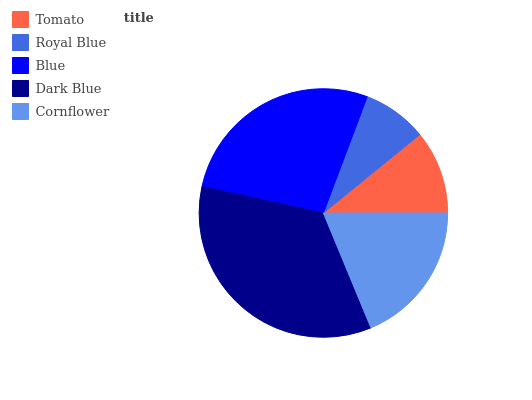Is Royal Blue the minimum?
Answer yes or no. Yes. Is Dark Blue the maximum?
Answer yes or no. Yes. Is Blue the minimum?
Answer yes or no. No. Is Blue the maximum?
Answer yes or no. No. Is Blue greater than Royal Blue?
Answer yes or no. Yes. Is Royal Blue less than Blue?
Answer yes or no. Yes. Is Royal Blue greater than Blue?
Answer yes or no. No. Is Blue less than Royal Blue?
Answer yes or no. No. Is Cornflower the high median?
Answer yes or no. Yes. Is Cornflower the low median?
Answer yes or no. Yes. Is Blue the high median?
Answer yes or no. No. Is Blue the low median?
Answer yes or no. No. 